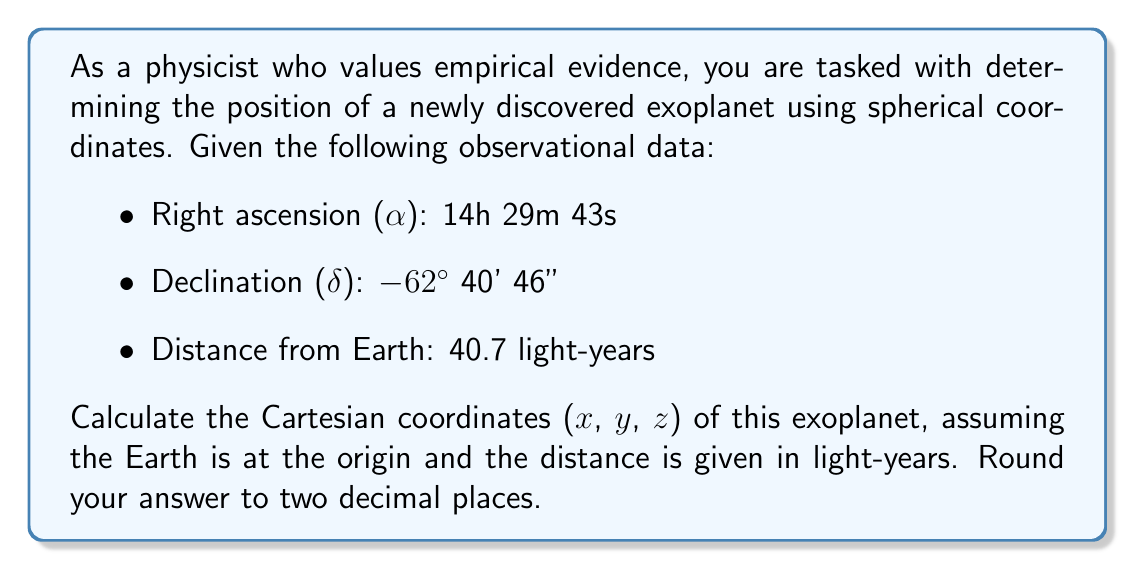Provide a solution to this math problem. To solve this problem, we need to convert the given spherical coordinates to Cartesian coordinates. The process involves the following steps:

1. Convert right ascension and declination to radians:
   Right ascension (α): 
   $\alpha = (14 + \frac{29}{60} + \frac{43}{3600}) \cdot \frac{\pi}{12} \approx 3.7672$ radians

   Declination (δ):
   $\delta = -(62 + \frac{40}{60} + \frac{46}{3600}) \cdot \frac{\pi}{180} \approx -1.0941$ radians

2. Use the distance (r) as given: 40.7 light-years

3. Apply the conversion formulas from spherical to Cartesian coordinates:
   $$x = r \cos(\delta) \cos(\alpha)$$
   $$y = r \cos(\delta) \sin(\alpha)$$
   $$z = r \sin(\delta)$$

4. Calculate the Cartesian coordinates:
   $$x = 40.7 \cdot \cos(-1.0941) \cdot \cos(3.7672) \approx -11.52$$
   $$y = 40.7 \cdot \cos(-1.0941) \cdot \sin(3.7672) \approx -36.29$$
   $$z = 40.7 \cdot \sin(-1.0941) \approx -36.14$$

5. Round the results to two decimal places.

This method provides empirical coordinates based on observational data, which can be used for further analysis and verification of the exoplanet's position.
Answer: The Cartesian coordinates of the exoplanet are approximately:
x = -11.52 light-years
y = -36.29 light-years
z = -36.14 light-years 